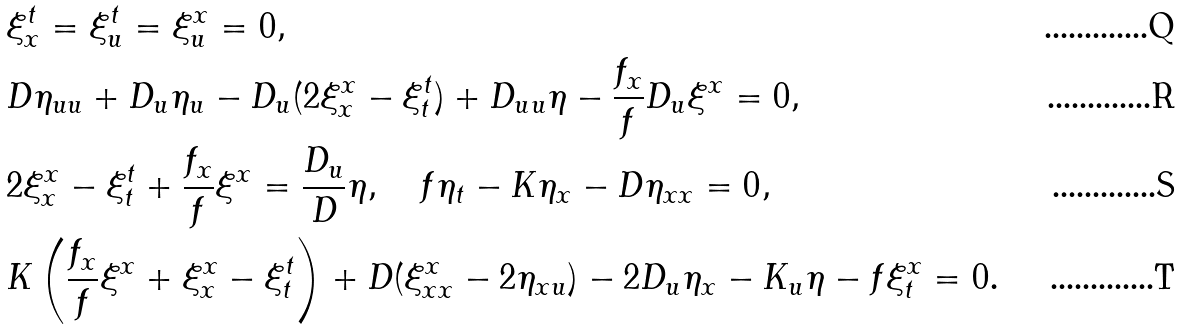<formula> <loc_0><loc_0><loc_500><loc_500>& \xi ^ { t } _ { x } = \xi ^ { t } _ { u } = \xi ^ { x } _ { u } = 0 , \\ & D \eta _ { u u } + D _ { u } \eta _ { u } - D _ { u } ( 2 \xi ^ { x } _ { x } - \xi ^ { t } _ { t } ) + D _ { u u } \eta - \frac { f _ { x } } f D _ { u } \xi ^ { x } = 0 , \\ & 2 \xi ^ { x } _ { x } - \xi ^ { t } _ { t } + \frac { f _ { x } } f \xi ^ { x } = \frac { D _ { u } } D \eta , \quad f \eta _ { t } - K \eta _ { x } - D \eta _ { x x } = 0 , \\ & K \left ( \frac { f _ { x } } f \xi ^ { x } + \xi ^ { x } _ { x } - \xi ^ { t } _ { t } \right ) + D ( \xi ^ { x } _ { x x } - 2 \eta _ { x u } ) - 2 D _ { u } \eta _ { x } - K _ { u } \eta - f \xi ^ { x } _ { t } = 0 .</formula> 